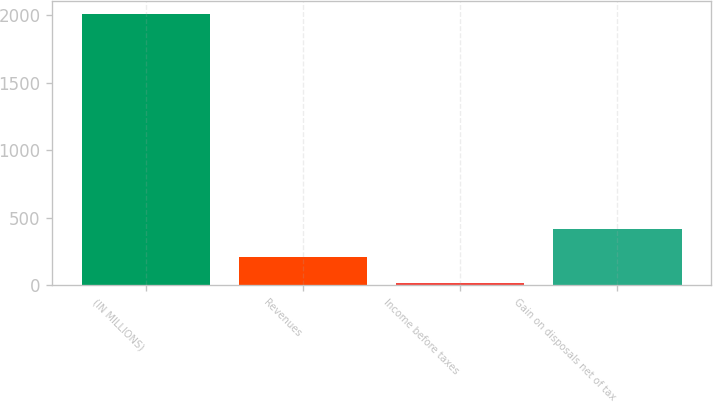Convert chart to OTSL. <chart><loc_0><loc_0><loc_500><loc_500><bar_chart><fcel>(IN MILLIONS)<fcel>Revenues<fcel>Income before taxes<fcel>Gain on disposals net of tax<nl><fcel>2006<fcel>212.3<fcel>13<fcel>416<nl></chart> 